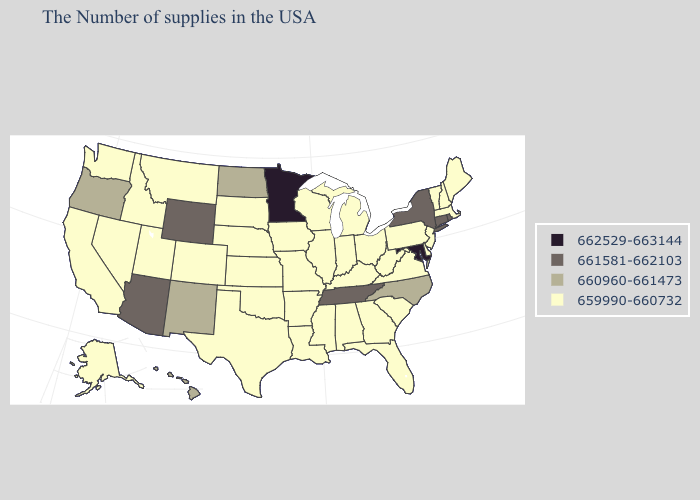Does Missouri have the lowest value in the MidWest?
Answer briefly. Yes. Name the states that have a value in the range 662529-663144?
Be succinct. Maryland, Minnesota. Does the map have missing data?
Concise answer only. No. Does Hawaii have the same value as Oregon?
Answer briefly. Yes. Does Minnesota have the highest value in the USA?
Be succinct. Yes. What is the value of North Carolina?
Quick response, please. 660960-661473. What is the value of Delaware?
Quick response, please. 659990-660732. What is the value of Arkansas?
Quick response, please. 659990-660732. Name the states that have a value in the range 659990-660732?
Write a very short answer. Maine, Massachusetts, New Hampshire, Vermont, New Jersey, Delaware, Pennsylvania, Virginia, South Carolina, West Virginia, Ohio, Florida, Georgia, Michigan, Kentucky, Indiana, Alabama, Wisconsin, Illinois, Mississippi, Louisiana, Missouri, Arkansas, Iowa, Kansas, Nebraska, Oklahoma, Texas, South Dakota, Colorado, Utah, Montana, Idaho, Nevada, California, Washington, Alaska. Name the states that have a value in the range 660960-661473?
Answer briefly. North Carolina, North Dakota, New Mexico, Oregon, Hawaii. Name the states that have a value in the range 662529-663144?
Be succinct. Maryland, Minnesota. Among the states that border Montana , does Wyoming have the highest value?
Keep it brief. Yes. What is the highest value in states that border Alabama?
Concise answer only. 661581-662103. What is the value of Kansas?
Answer briefly. 659990-660732. 